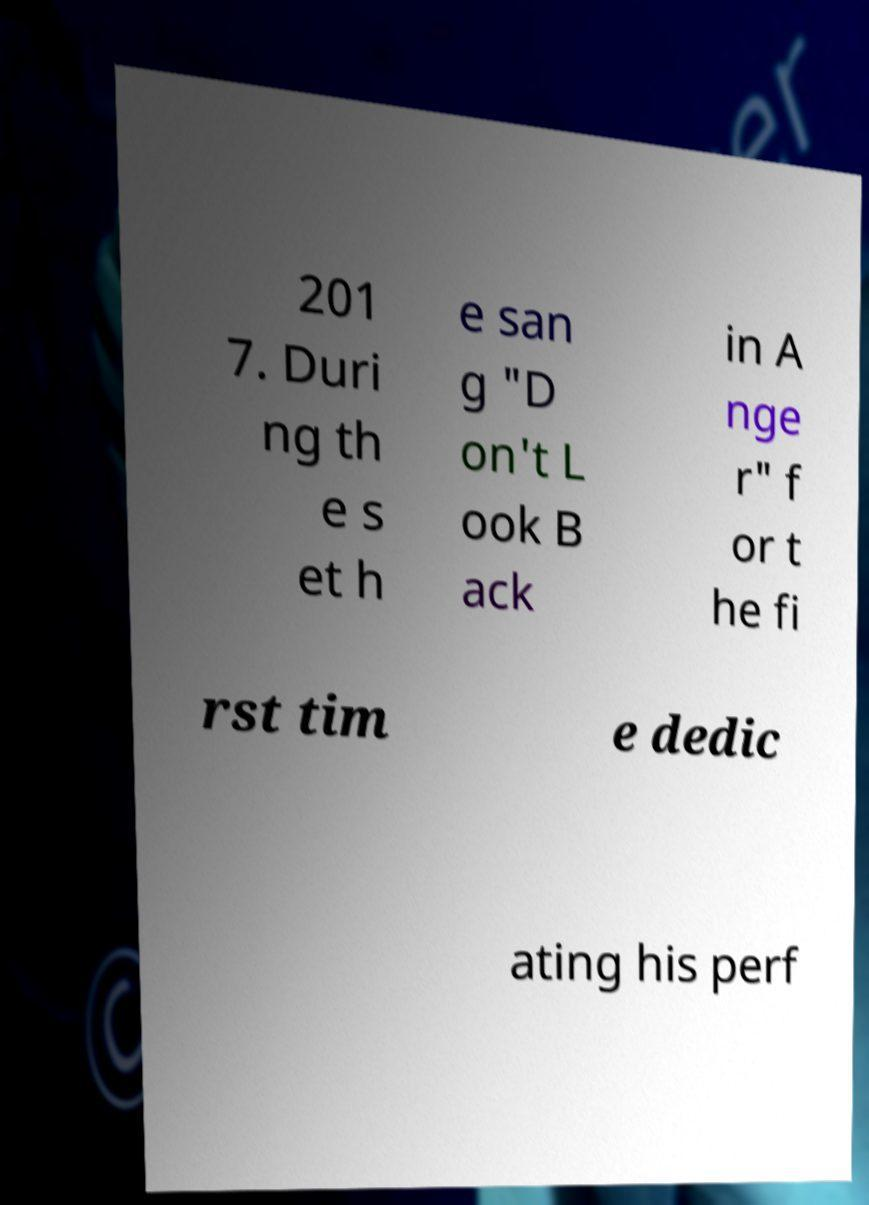For documentation purposes, I need the text within this image transcribed. Could you provide that? 201 7. Duri ng th e s et h e san g "D on't L ook B ack in A nge r" f or t he fi rst tim e dedic ating his perf 